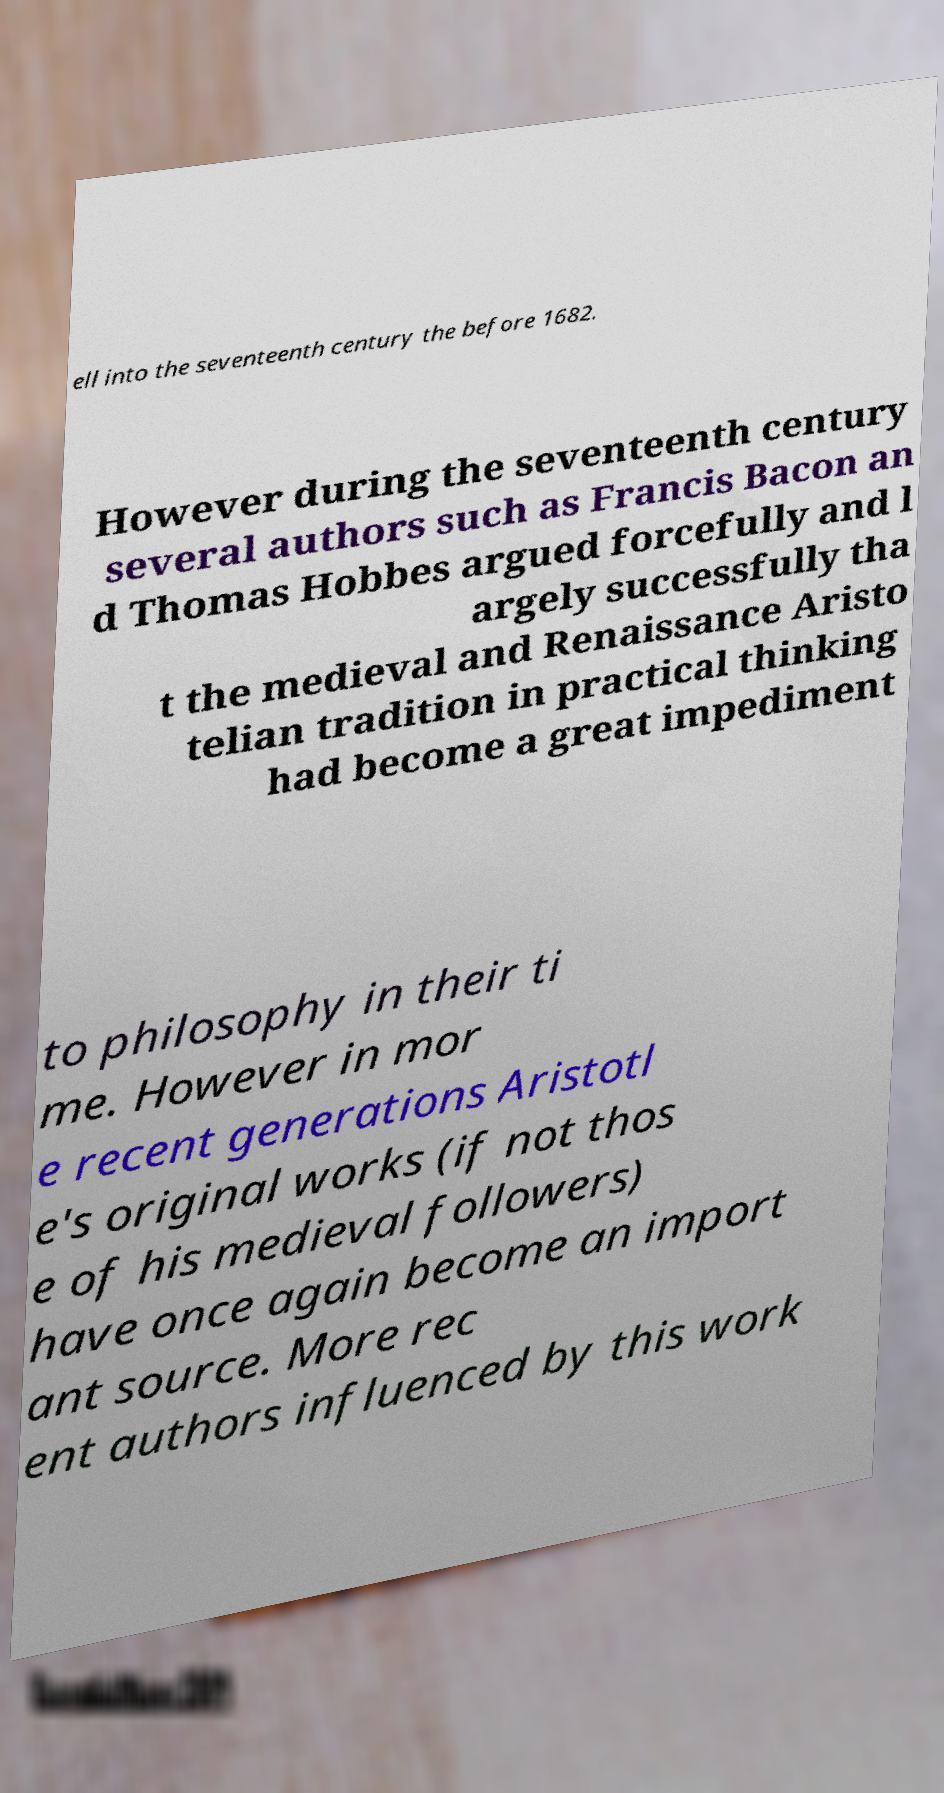There's text embedded in this image that I need extracted. Can you transcribe it verbatim? ell into the seventeenth century the before 1682. However during the seventeenth century several authors such as Francis Bacon an d Thomas Hobbes argued forcefully and l argely successfully tha t the medieval and Renaissance Aristo telian tradition in practical thinking had become a great impediment to philosophy in their ti me. However in mor e recent generations Aristotl e's original works (if not thos e of his medieval followers) have once again become an import ant source. More rec ent authors influenced by this work 